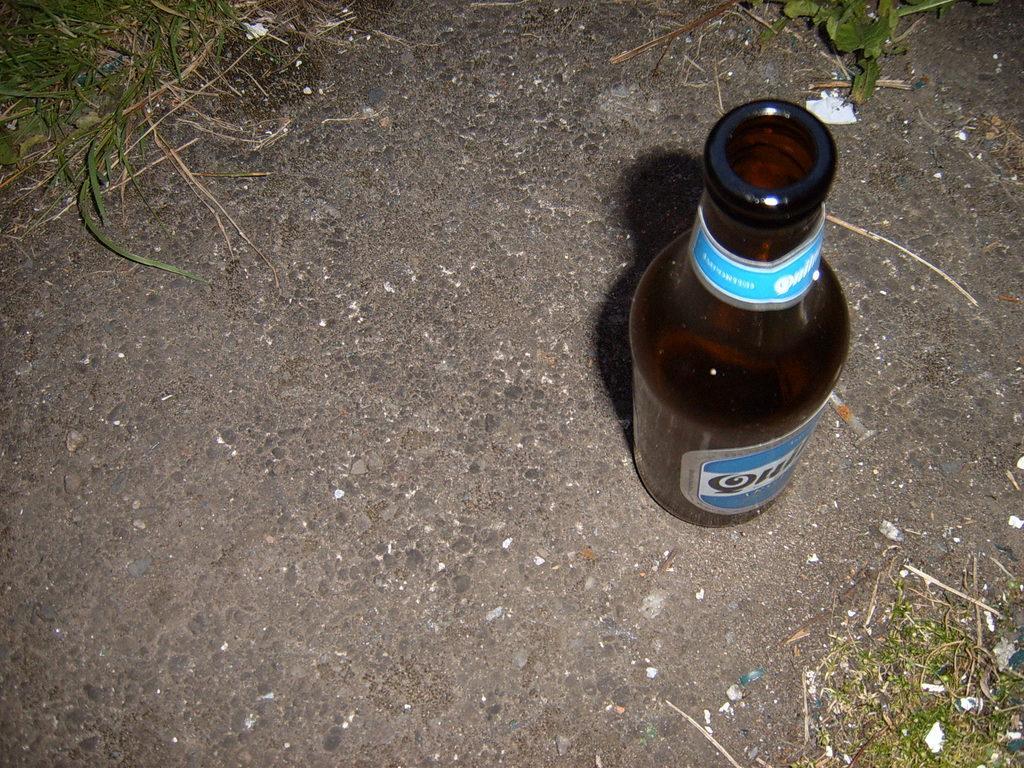Please provide a concise description of this image. In this image, we can see a bottle. We can see the ground and some grass. 